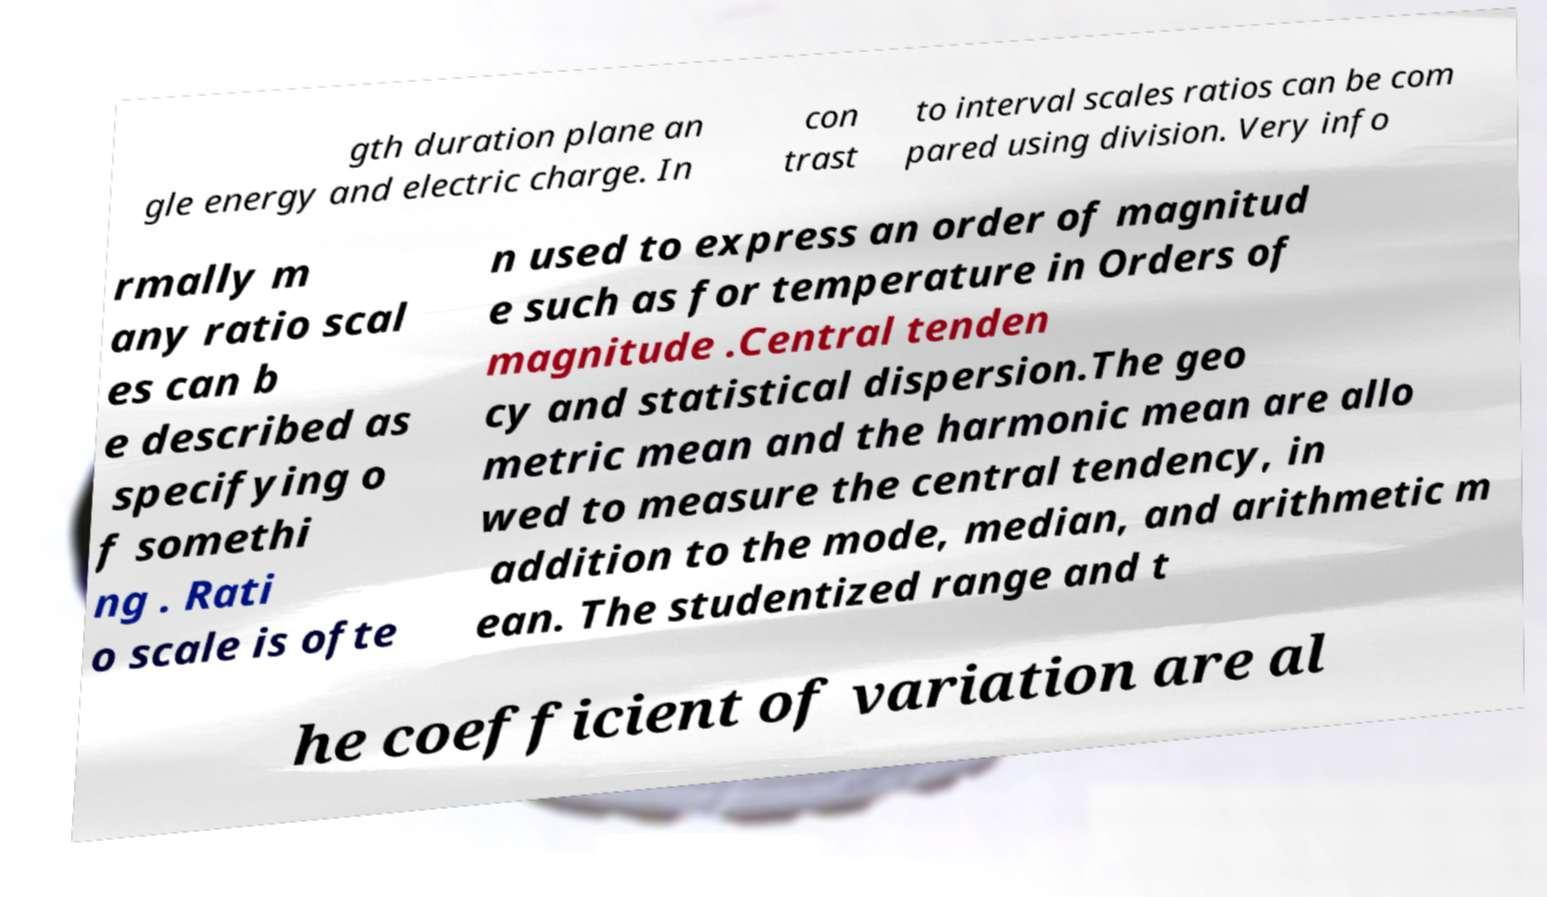What messages or text are displayed in this image? I need them in a readable, typed format. gth duration plane an gle energy and electric charge. In con trast to interval scales ratios can be com pared using division. Very info rmally m any ratio scal es can b e described as specifying o f somethi ng . Rati o scale is ofte n used to express an order of magnitud e such as for temperature in Orders of magnitude .Central tenden cy and statistical dispersion.The geo metric mean and the harmonic mean are allo wed to measure the central tendency, in addition to the mode, median, and arithmetic m ean. The studentized range and t he coefficient of variation are al 